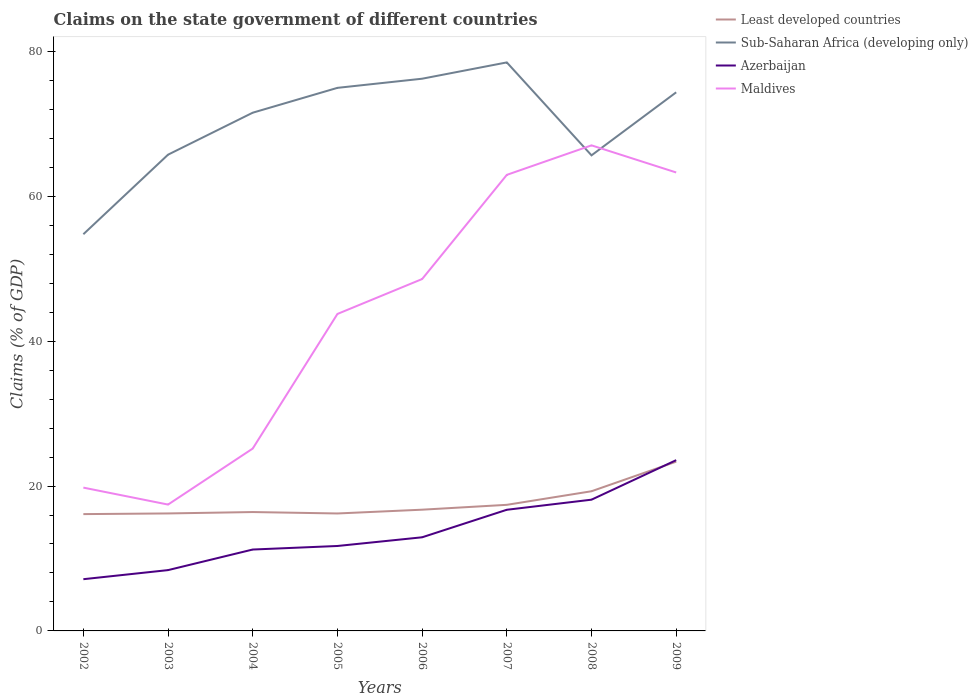How many different coloured lines are there?
Your response must be concise. 4. Does the line corresponding to Maldives intersect with the line corresponding to Least developed countries?
Your response must be concise. No. Across all years, what is the maximum percentage of GDP claimed on the state government in Sub-Saharan Africa (developing only)?
Offer a very short reply. 54.76. What is the total percentage of GDP claimed on the state government in Azerbaijan in the graph?
Your response must be concise. -1.69. What is the difference between the highest and the second highest percentage of GDP claimed on the state government in Maldives?
Provide a short and direct response. 49.59. Is the percentage of GDP claimed on the state government in Maldives strictly greater than the percentage of GDP claimed on the state government in Azerbaijan over the years?
Offer a terse response. No. How many lines are there?
Provide a short and direct response. 4. What is the difference between two consecutive major ticks on the Y-axis?
Provide a short and direct response. 20. Are the values on the major ticks of Y-axis written in scientific E-notation?
Make the answer very short. No. Does the graph contain any zero values?
Your response must be concise. No. How many legend labels are there?
Make the answer very short. 4. What is the title of the graph?
Offer a terse response. Claims on the state government of different countries. Does "East Asia (all income levels)" appear as one of the legend labels in the graph?
Make the answer very short. No. What is the label or title of the Y-axis?
Make the answer very short. Claims (% of GDP). What is the Claims (% of GDP) in Least developed countries in 2002?
Provide a short and direct response. 16.13. What is the Claims (% of GDP) in Sub-Saharan Africa (developing only) in 2002?
Offer a very short reply. 54.76. What is the Claims (% of GDP) of Azerbaijan in 2002?
Provide a short and direct response. 7.14. What is the Claims (% of GDP) of Maldives in 2002?
Your response must be concise. 19.78. What is the Claims (% of GDP) in Least developed countries in 2003?
Your response must be concise. 16.22. What is the Claims (% of GDP) of Sub-Saharan Africa (developing only) in 2003?
Ensure brevity in your answer.  65.75. What is the Claims (% of GDP) in Azerbaijan in 2003?
Give a very brief answer. 8.4. What is the Claims (% of GDP) in Maldives in 2003?
Your answer should be very brief. 17.44. What is the Claims (% of GDP) of Least developed countries in 2004?
Provide a short and direct response. 16.41. What is the Claims (% of GDP) of Sub-Saharan Africa (developing only) in 2004?
Give a very brief answer. 71.54. What is the Claims (% of GDP) in Azerbaijan in 2004?
Offer a very short reply. 11.24. What is the Claims (% of GDP) in Maldives in 2004?
Offer a very short reply. 25.18. What is the Claims (% of GDP) in Least developed countries in 2005?
Provide a short and direct response. 16.21. What is the Claims (% of GDP) of Sub-Saharan Africa (developing only) in 2005?
Give a very brief answer. 74.97. What is the Claims (% of GDP) in Azerbaijan in 2005?
Your answer should be very brief. 11.73. What is the Claims (% of GDP) of Maldives in 2005?
Keep it short and to the point. 43.76. What is the Claims (% of GDP) in Least developed countries in 2006?
Ensure brevity in your answer.  16.74. What is the Claims (% of GDP) of Sub-Saharan Africa (developing only) in 2006?
Give a very brief answer. 76.23. What is the Claims (% of GDP) of Azerbaijan in 2006?
Give a very brief answer. 12.93. What is the Claims (% of GDP) of Maldives in 2006?
Make the answer very short. 48.58. What is the Claims (% of GDP) in Least developed countries in 2007?
Offer a terse response. 17.41. What is the Claims (% of GDP) in Sub-Saharan Africa (developing only) in 2007?
Provide a succinct answer. 78.48. What is the Claims (% of GDP) in Azerbaijan in 2007?
Keep it short and to the point. 16.73. What is the Claims (% of GDP) of Maldives in 2007?
Make the answer very short. 62.96. What is the Claims (% of GDP) of Least developed countries in 2008?
Provide a succinct answer. 19.28. What is the Claims (% of GDP) of Sub-Saharan Africa (developing only) in 2008?
Provide a short and direct response. 65.65. What is the Claims (% of GDP) of Azerbaijan in 2008?
Your response must be concise. 18.12. What is the Claims (% of GDP) of Maldives in 2008?
Your response must be concise. 67.03. What is the Claims (% of GDP) in Least developed countries in 2009?
Offer a very short reply. 23.37. What is the Claims (% of GDP) of Sub-Saharan Africa (developing only) in 2009?
Provide a short and direct response. 74.35. What is the Claims (% of GDP) of Azerbaijan in 2009?
Your answer should be compact. 23.58. What is the Claims (% of GDP) in Maldives in 2009?
Your answer should be compact. 63.29. Across all years, what is the maximum Claims (% of GDP) in Least developed countries?
Ensure brevity in your answer.  23.37. Across all years, what is the maximum Claims (% of GDP) in Sub-Saharan Africa (developing only)?
Your response must be concise. 78.48. Across all years, what is the maximum Claims (% of GDP) in Azerbaijan?
Make the answer very short. 23.58. Across all years, what is the maximum Claims (% of GDP) in Maldives?
Keep it short and to the point. 67.03. Across all years, what is the minimum Claims (% of GDP) in Least developed countries?
Give a very brief answer. 16.13. Across all years, what is the minimum Claims (% of GDP) in Sub-Saharan Africa (developing only)?
Provide a succinct answer. 54.76. Across all years, what is the minimum Claims (% of GDP) in Azerbaijan?
Offer a terse response. 7.14. Across all years, what is the minimum Claims (% of GDP) in Maldives?
Make the answer very short. 17.44. What is the total Claims (% of GDP) of Least developed countries in the graph?
Provide a short and direct response. 141.76. What is the total Claims (% of GDP) in Sub-Saharan Africa (developing only) in the graph?
Make the answer very short. 561.74. What is the total Claims (% of GDP) in Azerbaijan in the graph?
Offer a terse response. 109.84. What is the total Claims (% of GDP) of Maldives in the graph?
Ensure brevity in your answer.  348.02. What is the difference between the Claims (% of GDP) of Least developed countries in 2002 and that in 2003?
Your answer should be very brief. -0.09. What is the difference between the Claims (% of GDP) of Sub-Saharan Africa (developing only) in 2002 and that in 2003?
Offer a very short reply. -10.98. What is the difference between the Claims (% of GDP) in Azerbaijan in 2002 and that in 2003?
Your answer should be compact. -1.25. What is the difference between the Claims (% of GDP) of Maldives in 2002 and that in 2003?
Make the answer very short. 2.34. What is the difference between the Claims (% of GDP) in Least developed countries in 2002 and that in 2004?
Your answer should be compact. -0.28. What is the difference between the Claims (% of GDP) in Sub-Saharan Africa (developing only) in 2002 and that in 2004?
Your answer should be very brief. -16.78. What is the difference between the Claims (% of GDP) in Azerbaijan in 2002 and that in 2004?
Provide a short and direct response. -4.1. What is the difference between the Claims (% of GDP) of Maldives in 2002 and that in 2004?
Your answer should be compact. -5.39. What is the difference between the Claims (% of GDP) of Least developed countries in 2002 and that in 2005?
Give a very brief answer. -0.09. What is the difference between the Claims (% of GDP) in Sub-Saharan Africa (developing only) in 2002 and that in 2005?
Provide a succinct answer. -20.21. What is the difference between the Claims (% of GDP) of Azerbaijan in 2002 and that in 2005?
Provide a short and direct response. -4.58. What is the difference between the Claims (% of GDP) of Maldives in 2002 and that in 2005?
Keep it short and to the point. -23.97. What is the difference between the Claims (% of GDP) in Least developed countries in 2002 and that in 2006?
Your response must be concise. -0.61. What is the difference between the Claims (% of GDP) of Sub-Saharan Africa (developing only) in 2002 and that in 2006?
Provide a succinct answer. -21.47. What is the difference between the Claims (% of GDP) of Azerbaijan in 2002 and that in 2006?
Offer a very short reply. -5.78. What is the difference between the Claims (% of GDP) in Maldives in 2002 and that in 2006?
Keep it short and to the point. -28.79. What is the difference between the Claims (% of GDP) of Least developed countries in 2002 and that in 2007?
Your answer should be very brief. -1.28. What is the difference between the Claims (% of GDP) in Sub-Saharan Africa (developing only) in 2002 and that in 2007?
Provide a short and direct response. -23.72. What is the difference between the Claims (% of GDP) of Azerbaijan in 2002 and that in 2007?
Ensure brevity in your answer.  -9.58. What is the difference between the Claims (% of GDP) of Maldives in 2002 and that in 2007?
Your answer should be compact. -43.17. What is the difference between the Claims (% of GDP) in Least developed countries in 2002 and that in 2008?
Provide a succinct answer. -3.16. What is the difference between the Claims (% of GDP) of Sub-Saharan Africa (developing only) in 2002 and that in 2008?
Your answer should be compact. -10.89. What is the difference between the Claims (% of GDP) of Azerbaijan in 2002 and that in 2008?
Offer a terse response. -10.98. What is the difference between the Claims (% of GDP) of Maldives in 2002 and that in 2008?
Offer a very short reply. -47.25. What is the difference between the Claims (% of GDP) in Least developed countries in 2002 and that in 2009?
Make the answer very short. -7.24. What is the difference between the Claims (% of GDP) of Sub-Saharan Africa (developing only) in 2002 and that in 2009?
Provide a succinct answer. -19.59. What is the difference between the Claims (% of GDP) in Azerbaijan in 2002 and that in 2009?
Your response must be concise. -16.43. What is the difference between the Claims (% of GDP) in Maldives in 2002 and that in 2009?
Provide a short and direct response. -43.51. What is the difference between the Claims (% of GDP) in Least developed countries in 2003 and that in 2004?
Ensure brevity in your answer.  -0.19. What is the difference between the Claims (% of GDP) of Sub-Saharan Africa (developing only) in 2003 and that in 2004?
Keep it short and to the point. -5.8. What is the difference between the Claims (% of GDP) in Azerbaijan in 2003 and that in 2004?
Provide a succinct answer. -2.84. What is the difference between the Claims (% of GDP) in Maldives in 2003 and that in 2004?
Offer a terse response. -7.74. What is the difference between the Claims (% of GDP) of Least developed countries in 2003 and that in 2005?
Provide a short and direct response. 0. What is the difference between the Claims (% of GDP) of Sub-Saharan Africa (developing only) in 2003 and that in 2005?
Offer a very short reply. -9.22. What is the difference between the Claims (% of GDP) of Azerbaijan in 2003 and that in 2005?
Provide a short and direct response. -3.33. What is the difference between the Claims (% of GDP) in Maldives in 2003 and that in 2005?
Offer a very short reply. -26.32. What is the difference between the Claims (% of GDP) in Least developed countries in 2003 and that in 2006?
Provide a short and direct response. -0.52. What is the difference between the Claims (% of GDP) of Sub-Saharan Africa (developing only) in 2003 and that in 2006?
Your answer should be very brief. -10.49. What is the difference between the Claims (% of GDP) of Azerbaijan in 2003 and that in 2006?
Your answer should be compact. -4.53. What is the difference between the Claims (% of GDP) of Maldives in 2003 and that in 2006?
Offer a terse response. -31.13. What is the difference between the Claims (% of GDP) in Least developed countries in 2003 and that in 2007?
Your response must be concise. -1.19. What is the difference between the Claims (% of GDP) of Sub-Saharan Africa (developing only) in 2003 and that in 2007?
Give a very brief answer. -12.74. What is the difference between the Claims (% of GDP) of Azerbaijan in 2003 and that in 2007?
Your answer should be compact. -8.33. What is the difference between the Claims (% of GDP) in Maldives in 2003 and that in 2007?
Your answer should be compact. -45.52. What is the difference between the Claims (% of GDP) in Least developed countries in 2003 and that in 2008?
Your answer should be compact. -3.06. What is the difference between the Claims (% of GDP) of Sub-Saharan Africa (developing only) in 2003 and that in 2008?
Make the answer very short. 0.09. What is the difference between the Claims (% of GDP) of Azerbaijan in 2003 and that in 2008?
Give a very brief answer. -9.72. What is the difference between the Claims (% of GDP) in Maldives in 2003 and that in 2008?
Offer a very short reply. -49.59. What is the difference between the Claims (% of GDP) of Least developed countries in 2003 and that in 2009?
Your response must be concise. -7.15. What is the difference between the Claims (% of GDP) in Sub-Saharan Africa (developing only) in 2003 and that in 2009?
Provide a succinct answer. -8.61. What is the difference between the Claims (% of GDP) of Azerbaijan in 2003 and that in 2009?
Your response must be concise. -15.18. What is the difference between the Claims (% of GDP) in Maldives in 2003 and that in 2009?
Keep it short and to the point. -45.85. What is the difference between the Claims (% of GDP) in Least developed countries in 2004 and that in 2005?
Offer a terse response. 0.2. What is the difference between the Claims (% of GDP) of Sub-Saharan Africa (developing only) in 2004 and that in 2005?
Your answer should be compact. -3.43. What is the difference between the Claims (% of GDP) of Azerbaijan in 2004 and that in 2005?
Offer a very short reply. -0.49. What is the difference between the Claims (% of GDP) of Maldives in 2004 and that in 2005?
Keep it short and to the point. -18.58. What is the difference between the Claims (% of GDP) of Least developed countries in 2004 and that in 2006?
Your answer should be very brief. -0.33. What is the difference between the Claims (% of GDP) in Sub-Saharan Africa (developing only) in 2004 and that in 2006?
Ensure brevity in your answer.  -4.69. What is the difference between the Claims (% of GDP) of Azerbaijan in 2004 and that in 2006?
Provide a short and direct response. -1.69. What is the difference between the Claims (% of GDP) of Maldives in 2004 and that in 2006?
Provide a succinct answer. -23.4. What is the difference between the Claims (% of GDP) in Least developed countries in 2004 and that in 2007?
Offer a terse response. -1. What is the difference between the Claims (% of GDP) in Sub-Saharan Africa (developing only) in 2004 and that in 2007?
Make the answer very short. -6.94. What is the difference between the Claims (% of GDP) in Azerbaijan in 2004 and that in 2007?
Make the answer very short. -5.49. What is the difference between the Claims (% of GDP) of Maldives in 2004 and that in 2007?
Offer a terse response. -37.78. What is the difference between the Claims (% of GDP) of Least developed countries in 2004 and that in 2008?
Make the answer very short. -2.87. What is the difference between the Claims (% of GDP) of Sub-Saharan Africa (developing only) in 2004 and that in 2008?
Your answer should be compact. 5.89. What is the difference between the Claims (% of GDP) of Azerbaijan in 2004 and that in 2008?
Provide a succinct answer. -6.88. What is the difference between the Claims (% of GDP) of Maldives in 2004 and that in 2008?
Your answer should be compact. -41.85. What is the difference between the Claims (% of GDP) in Least developed countries in 2004 and that in 2009?
Provide a succinct answer. -6.96. What is the difference between the Claims (% of GDP) in Sub-Saharan Africa (developing only) in 2004 and that in 2009?
Provide a succinct answer. -2.81. What is the difference between the Claims (% of GDP) of Azerbaijan in 2004 and that in 2009?
Offer a very short reply. -12.34. What is the difference between the Claims (% of GDP) of Maldives in 2004 and that in 2009?
Provide a short and direct response. -38.11. What is the difference between the Claims (% of GDP) of Least developed countries in 2005 and that in 2006?
Make the answer very short. -0.52. What is the difference between the Claims (% of GDP) in Sub-Saharan Africa (developing only) in 2005 and that in 2006?
Your answer should be compact. -1.26. What is the difference between the Claims (% of GDP) of Azerbaijan in 2005 and that in 2006?
Provide a short and direct response. -1.2. What is the difference between the Claims (% of GDP) of Maldives in 2005 and that in 2006?
Provide a succinct answer. -4.82. What is the difference between the Claims (% of GDP) in Least developed countries in 2005 and that in 2007?
Keep it short and to the point. -1.19. What is the difference between the Claims (% of GDP) of Sub-Saharan Africa (developing only) in 2005 and that in 2007?
Offer a terse response. -3.51. What is the difference between the Claims (% of GDP) in Azerbaijan in 2005 and that in 2007?
Your answer should be compact. -5. What is the difference between the Claims (% of GDP) of Maldives in 2005 and that in 2007?
Keep it short and to the point. -19.2. What is the difference between the Claims (% of GDP) in Least developed countries in 2005 and that in 2008?
Keep it short and to the point. -3.07. What is the difference between the Claims (% of GDP) of Sub-Saharan Africa (developing only) in 2005 and that in 2008?
Keep it short and to the point. 9.32. What is the difference between the Claims (% of GDP) of Azerbaijan in 2005 and that in 2008?
Your response must be concise. -6.39. What is the difference between the Claims (% of GDP) in Maldives in 2005 and that in 2008?
Offer a very short reply. -23.27. What is the difference between the Claims (% of GDP) of Least developed countries in 2005 and that in 2009?
Offer a very short reply. -7.15. What is the difference between the Claims (% of GDP) of Sub-Saharan Africa (developing only) in 2005 and that in 2009?
Your answer should be compact. 0.62. What is the difference between the Claims (% of GDP) in Azerbaijan in 2005 and that in 2009?
Provide a short and direct response. -11.85. What is the difference between the Claims (% of GDP) of Maldives in 2005 and that in 2009?
Keep it short and to the point. -19.53. What is the difference between the Claims (% of GDP) in Least developed countries in 2006 and that in 2007?
Give a very brief answer. -0.67. What is the difference between the Claims (% of GDP) of Sub-Saharan Africa (developing only) in 2006 and that in 2007?
Provide a short and direct response. -2.25. What is the difference between the Claims (% of GDP) of Azerbaijan in 2006 and that in 2007?
Ensure brevity in your answer.  -3.8. What is the difference between the Claims (% of GDP) in Maldives in 2006 and that in 2007?
Your response must be concise. -14.38. What is the difference between the Claims (% of GDP) in Least developed countries in 2006 and that in 2008?
Make the answer very short. -2.55. What is the difference between the Claims (% of GDP) in Sub-Saharan Africa (developing only) in 2006 and that in 2008?
Ensure brevity in your answer.  10.58. What is the difference between the Claims (% of GDP) in Azerbaijan in 2006 and that in 2008?
Provide a short and direct response. -5.19. What is the difference between the Claims (% of GDP) in Maldives in 2006 and that in 2008?
Offer a terse response. -18.46. What is the difference between the Claims (% of GDP) in Least developed countries in 2006 and that in 2009?
Ensure brevity in your answer.  -6.63. What is the difference between the Claims (% of GDP) of Sub-Saharan Africa (developing only) in 2006 and that in 2009?
Your response must be concise. 1.88. What is the difference between the Claims (% of GDP) in Azerbaijan in 2006 and that in 2009?
Make the answer very short. -10.65. What is the difference between the Claims (% of GDP) of Maldives in 2006 and that in 2009?
Give a very brief answer. -14.71. What is the difference between the Claims (% of GDP) in Least developed countries in 2007 and that in 2008?
Make the answer very short. -1.88. What is the difference between the Claims (% of GDP) of Sub-Saharan Africa (developing only) in 2007 and that in 2008?
Your answer should be very brief. 12.83. What is the difference between the Claims (% of GDP) of Azerbaijan in 2007 and that in 2008?
Provide a succinct answer. -1.39. What is the difference between the Claims (% of GDP) of Maldives in 2007 and that in 2008?
Your answer should be compact. -4.07. What is the difference between the Claims (% of GDP) of Least developed countries in 2007 and that in 2009?
Keep it short and to the point. -5.96. What is the difference between the Claims (% of GDP) of Sub-Saharan Africa (developing only) in 2007 and that in 2009?
Offer a very short reply. 4.13. What is the difference between the Claims (% of GDP) of Azerbaijan in 2007 and that in 2009?
Keep it short and to the point. -6.85. What is the difference between the Claims (% of GDP) of Maldives in 2007 and that in 2009?
Offer a very short reply. -0.33. What is the difference between the Claims (% of GDP) of Least developed countries in 2008 and that in 2009?
Provide a short and direct response. -4.08. What is the difference between the Claims (% of GDP) of Sub-Saharan Africa (developing only) in 2008 and that in 2009?
Offer a very short reply. -8.7. What is the difference between the Claims (% of GDP) of Azerbaijan in 2008 and that in 2009?
Keep it short and to the point. -5.46. What is the difference between the Claims (% of GDP) in Maldives in 2008 and that in 2009?
Offer a terse response. 3.74. What is the difference between the Claims (% of GDP) of Least developed countries in 2002 and the Claims (% of GDP) of Sub-Saharan Africa (developing only) in 2003?
Offer a very short reply. -49.62. What is the difference between the Claims (% of GDP) of Least developed countries in 2002 and the Claims (% of GDP) of Azerbaijan in 2003?
Provide a short and direct response. 7.73. What is the difference between the Claims (% of GDP) in Least developed countries in 2002 and the Claims (% of GDP) in Maldives in 2003?
Keep it short and to the point. -1.32. What is the difference between the Claims (% of GDP) of Sub-Saharan Africa (developing only) in 2002 and the Claims (% of GDP) of Azerbaijan in 2003?
Offer a very short reply. 46.37. What is the difference between the Claims (% of GDP) in Sub-Saharan Africa (developing only) in 2002 and the Claims (% of GDP) in Maldives in 2003?
Offer a very short reply. 37.32. What is the difference between the Claims (% of GDP) of Azerbaijan in 2002 and the Claims (% of GDP) of Maldives in 2003?
Offer a terse response. -10.3. What is the difference between the Claims (% of GDP) in Least developed countries in 2002 and the Claims (% of GDP) in Sub-Saharan Africa (developing only) in 2004?
Your answer should be compact. -55.42. What is the difference between the Claims (% of GDP) of Least developed countries in 2002 and the Claims (% of GDP) of Azerbaijan in 2004?
Make the answer very short. 4.89. What is the difference between the Claims (% of GDP) in Least developed countries in 2002 and the Claims (% of GDP) in Maldives in 2004?
Make the answer very short. -9.05. What is the difference between the Claims (% of GDP) in Sub-Saharan Africa (developing only) in 2002 and the Claims (% of GDP) in Azerbaijan in 2004?
Make the answer very short. 43.53. What is the difference between the Claims (% of GDP) in Sub-Saharan Africa (developing only) in 2002 and the Claims (% of GDP) in Maldives in 2004?
Offer a very short reply. 29.59. What is the difference between the Claims (% of GDP) in Azerbaijan in 2002 and the Claims (% of GDP) in Maldives in 2004?
Make the answer very short. -18.04. What is the difference between the Claims (% of GDP) of Least developed countries in 2002 and the Claims (% of GDP) of Sub-Saharan Africa (developing only) in 2005?
Give a very brief answer. -58.84. What is the difference between the Claims (% of GDP) of Least developed countries in 2002 and the Claims (% of GDP) of Maldives in 2005?
Offer a very short reply. -27.63. What is the difference between the Claims (% of GDP) of Sub-Saharan Africa (developing only) in 2002 and the Claims (% of GDP) of Azerbaijan in 2005?
Your answer should be very brief. 43.04. What is the difference between the Claims (% of GDP) in Sub-Saharan Africa (developing only) in 2002 and the Claims (% of GDP) in Maldives in 2005?
Your response must be concise. 11.01. What is the difference between the Claims (% of GDP) of Azerbaijan in 2002 and the Claims (% of GDP) of Maldives in 2005?
Provide a short and direct response. -36.62. What is the difference between the Claims (% of GDP) of Least developed countries in 2002 and the Claims (% of GDP) of Sub-Saharan Africa (developing only) in 2006?
Your answer should be compact. -60.11. What is the difference between the Claims (% of GDP) in Least developed countries in 2002 and the Claims (% of GDP) in Azerbaijan in 2006?
Make the answer very short. 3.2. What is the difference between the Claims (% of GDP) of Least developed countries in 2002 and the Claims (% of GDP) of Maldives in 2006?
Provide a short and direct response. -32.45. What is the difference between the Claims (% of GDP) in Sub-Saharan Africa (developing only) in 2002 and the Claims (% of GDP) in Azerbaijan in 2006?
Your answer should be compact. 41.84. What is the difference between the Claims (% of GDP) of Sub-Saharan Africa (developing only) in 2002 and the Claims (% of GDP) of Maldives in 2006?
Your answer should be compact. 6.19. What is the difference between the Claims (% of GDP) in Azerbaijan in 2002 and the Claims (% of GDP) in Maldives in 2006?
Offer a very short reply. -41.43. What is the difference between the Claims (% of GDP) of Least developed countries in 2002 and the Claims (% of GDP) of Sub-Saharan Africa (developing only) in 2007?
Your answer should be compact. -62.36. What is the difference between the Claims (% of GDP) of Least developed countries in 2002 and the Claims (% of GDP) of Azerbaijan in 2007?
Make the answer very short. -0.6. What is the difference between the Claims (% of GDP) in Least developed countries in 2002 and the Claims (% of GDP) in Maldives in 2007?
Your answer should be very brief. -46.83. What is the difference between the Claims (% of GDP) in Sub-Saharan Africa (developing only) in 2002 and the Claims (% of GDP) in Azerbaijan in 2007?
Your answer should be very brief. 38.04. What is the difference between the Claims (% of GDP) of Sub-Saharan Africa (developing only) in 2002 and the Claims (% of GDP) of Maldives in 2007?
Provide a short and direct response. -8.19. What is the difference between the Claims (% of GDP) in Azerbaijan in 2002 and the Claims (% of GDP) in Maldives in 2007?
Your answer should be very brief. -55.82. What is the difference between the Claims (% of GDP) in Least developed countries in 2002 and the Claims (% of GDP) in Sub-Saharan Africa (developing only) in 2008?
Make the answer very short. -49.53. What is the difference between the Claims (% of GDP) in Least developed countries in 2002 and the Claims (% of GDP) in Azerbaijan in 2008?
Offer a terse response. -1.99. What is the difference between the Claims (% of GDP) of Least developed countries in 2002 and the Claims (% of GDP) of Maldives in 2008?
Your response must be concise. -50.91. What is the difference between the Claims (% of GDP) of Sub-Saharan Africa (developing only) in 2002 and the Claims (% of GDP) of Azerbaijan in 2008?
Your response must be concise. 36.65. What is the difference between the Claims (% of GDP) of Sub-Saharan Africa (developing only) in 2002 and the Claims (% of GDP) of Maldives in 2008?
Ensure brevity in your answer.  -12.27. What is the difference between the Claims (% of GDP) in Azerbaijan in 2002 and the Claims (% of GDP) in Maldives in 2008?
Offer a terse response. -59.89. What is the difference between the Claims (% of GDP) in Least developed countries in 2002 and the Claims (% of GDP) in Sub-Saharan Africa (developing only) in 2009?
Give a very brief answer. -58.23. What is the difference between the Claims (% of GDP) in Least developed countries in 2002 and the Claims (% of GDP) in Azerbaijan in 2009?
Your answer should be very brief. -7.45. What is the difference between the Claims (% of GDP) in Least developed countries in 2002 and the Claims (% of GDP) in Maldives in 2009?
Your answer should be compact. -47.16. What is the difference between the Claims (% of GDP) of Sub-Saharan Africa (developing only) in 2002 and the Claims (% of GDP) of Azerbaijan in 2009?
Your answer should be compact. 31.19. What is the difference between the Claims (% of GDP) of Sub-Saharan Africa (developing only) in 2002 and the Claims (% of GDP) of Maldives in 2009?
Keep it short and to the point. -8.53. What is the difference between the Claims (% of GDP) in Azerbaijan in 2002 and the Claims (% of GDP) in Maldives in 2009?
Ensure brevity in your answer.  -56.15. What is the difference between the Claims (% of GDP) in Least developed countries in 2003 and the Claims (% of GDP) in Sub-Saharan Africa (developing only) in 2004?
Offer a terse response. -55.32. What is the difference between the Claims (% of GDP) of Least developed countries in 2003 and the Claims (% of GDP) of Azerbaijan in 2004?
Ensure brevity in your answer.  4.98. What is the difference between the Claims (% of GDP) of Least developed countries in 2003 and the Claims (% of GDP) of Maldives in 2004?
Provide a short and direct response. -8.96. What is the difference between the Claims (% of GDP) in Sub-Saharan Africa (developing only) in 2003 and the Claims (% of GDP) in Azerbaijan in 2004?
Offer a very short reply. 54.51. What is the difference between the Claims (% of GDP) of Sub-Saharan Africa (developing only) in 2003 and the Claims (% of GDP) of Maldives in 2004?
Offer a terse response. 40.57. What is the difference between the Claims (% of GDP) of Azerbaijan in 2003 and the Claims (% of GDP) of Maldives in 2004?
Provide a succinct answer. -16.78. What is the difference between the Claims (% of GDP) of Least developed countries in 2003 and the Claims (% of GDP) of Sub-Saharan Africa (developing only) in 2005?
Provide a succinct answer. -58.75. What is the difference between the Claims (% of GDP) in Least developed countries in 2003 and the Claims (% of GDP) in Azerbaijan in 2005?
Ensure brevity in your answer.  4.49. What is the difference between the Claims (% of GDP) in Least developed countries in 2003 and the Claims (% of GDP) in Maldives in 2005?
Provide a succinct answer. -27.54. What is the difference between the Claims (% of GDP) in Sub-Saharan Africa (developing only) in 2003 and the Claims (% of GDP) in Azerbaijan in 2005?
Give a very brief answer. 54.02. What is the difference between the Claims (% of GDP) in Sub-Saharan Africa (developing only) in 2003 and the Claims (% of GDP) in Maldives in 2005?
Your answer should be very brief. 21.99. What is the difference between the Claims (% of GDP) of Azerbaijan in 2003 and the Claims (% of GDP) of Maldives in 2005?
Give a very brief answer. -35.36. What is the difference between the Claims (% of GDP) of Least developed countries in 2003 and the Claims (% of GDP) of Sub-Saharan Africa (developing only) in 2006?
Offer a terse response. -60.01. What is the difference between the Claims (% of GDP) of Least developed countries in 2003 and the Claims (% of GDP) of Azerbaijan in 2006?
Offer a terse response. 3.29. What is the difference between the Claims (% of GDP) in Least developed countries in 2003 and the Claims (% of GDP) in Maldives in 2006?
Provide a succinct answer. -32.36. What is the difference between the Claims (% of GDP) of Sub-Saharan Africa (developing only) in 2003 and the Claims (% of GDP) of Azerbaijan in 2006?
Your answer should be compact. 52.82. What is the difference between the Claims (% of GDP) of Sub-Saharan Africa (developing only) in 2003 and the Claims (% of GDP) of Maldives in 2006?
Your response must be concise. 17.17. What is the difference between the Claims (% of GDP) of Azerbaijan in 2003 and the Claims (% of GDP) of Maldives in 2006?
Give a very brief answer. -40.18. What is the difference between the Claims (% of GDP) in Least developed countries in 2003 and the Claims (% of GDP) in Sub-Saharan Africa (developing only) in 2007?
Offer a very short reply. -62.26. What is the difference between the Claims (% of GDP) of Least developed countries in 2003 and the Claims (% of GDP) of Azerbaijan in 2007?
Give a very brief answer. -0.51. What is the difference between the Claims (% of GDP) of Least developed countries in 2003 and the Claims (% of GDP) of Maldives in 2007?
Give a very brief answer. -46.74. What is the difference between the Claims (% of GDP) in Sub-Saharan Africa (developing only) in 2003 and the Claims (% of GDP) in Azerbaijan in 2007?
Your answer should be very brief. 49.02. What is the difference between the Claims (% of GDP) in Sub-Saharan Africa (developing only) in 2003 and the Claims (% of GDP) in Maldives in 2007?
Your response must be concise. 2.79. What is the difference between the Claims (% of GDP) in Azerbaijan in 2003 and the Claims (% of GDP) in Maldives in 2007?
Ensure brevity in your answer.  -54.56. What is the difference between the Claims (% of GDP) in Least developed countries in 2003 and the Claims (% of GDP) in Sub-Saharan Africa (developing only) in 2008?
Keep it short and to the point. -49.43. What is the difference between the Claims (% of GDP) of Least developed countries in 2003 and the Claims (% of GDP) of Azerbaijan in 2008?
Make the answer very short. -1.9. What is the difference between the Claims (% of GDP) in Least developed countries in 2003 and the Claims (% of GDP) in Maldives in 2008?
Keep it short and to the point. -50.81. What is the difference between the Claims (% of GDP) in Sub-Saharan Africa (developing only) in 2003 and the Claims (% of GDP) in Azerbaijan in 2008?
Your answer should be very brief. 47.63. What is the difference between the Claims (% of GDP) in Sub-Saharan Africa (developing only) in 2003 and the Claims (% of GDP) in Maldives in 2008?
Your response must be concise. -1.29. What is the difference between the Claims (% of GDP) in Azerbaijan in 2003 and the Claims (% of GDP) in Maldives in 2008?
Give a very brief answer. -58.64. What is the difference between the Claims (% of GDP) in Least developed countries in 2003 and the Claims (% of GDP) in Sub-Saharan Africa (developing only) in 2009?
Your answer should be very brief. -58.14. What is the difference between the Claims (% of GDP) in Least developed countries in 2003 and the Claims (% of GDP) in Azerbaijan in 2009?
Make the answer very short. -7.36. What is the difference between the Claims (% of GDP) in Least developed countries in 2003 and the Claims (% of GDP) in Maldives in 2009?
Your response must be concise. -47.07. What is the difference between the Claims (% of GDP) in Sub-Saharan Africa (developing only) in 2003 and the Claims (% of GDP) in Azerbaijan in 2009?
Give a very brief answer. 42.17. What is the difference between the Claims (% of GDP) of Sub-Saharan Africa (developing only) in 2003 and the Claims (% of GDP) of Maldives in 2009?
Provide a succinct answer. 2.46. What is the difference between the Claims (% of GDP) of Azerbaijan in 2003 and the Claims (% of GDP) of Maldives in 2009?
Your answer should be compact. -54.89. What is the difference between the Claims (% of GDP) in Least developed countries in 2004 and the Claims (% of GDP) in Sub-Saharan Africa (developing only) in 2005?
Your response must be concise. -58.56. What is the difference between the Claims (% of GDP) of Least developed countries in 2004 and the Claims (% of GDP) of Azerbaijan in 2005?
Your response must be concise. 4.68. What is the difference between the Claims (% of GDP) in Least developed countries in 2004 and the Claims (% of GDP) in Maldives in 2005?
Give a very brief answer. -27.35. What is the difference between the Claims (% of GDP) of Sub-Saharan Africa (developing only) in 2004 and the Claims (% of GDP) of Azerbaijan in 2005?
Offer a very short reply. 59.82. What is the difference between the Claims (% of GDP) in Sub-Saharan Africa (developing only) in 2004 and the Claims (% of GDP) in Maldives in 2005?
Provide a short and direct response. 27.78. What is the difference between the Claims (% of GDP) in Azerbaijan in 2004 and the Claims (% of GDP) in Maldives in 2005?
Give a very brief answer. -32.52. What is the difference between the Claims (% of GDP) in Least developed countries in 2004 and the Claims (% of GDP) in Sub-Saharan Africa (developing only) in 2006?
Offer a terse response. -59.82. What is the difference between the Claims (% of GDP) of Least developed countries in 2004 and the Claims (% of GDP) of Azerbaijan in 2006?
Give a very brief answer. 3.48. What is the difference between the Claims (% of GDP) of Least developed countries in 2004 and the Claims (% of GDP) of Maldives in 2006?
Offer a very short reply. -32.17. What is the difference between the Claims (% of GDP) of Sub-Saharan Africa (developing only) in 2004 and the Claims (% of GDP) of Azerbaijan in 2006?
Provide a succinct answer. 58.62. What is the difference between the Claims (% of GDP) of Sub-Saharan Africa (developing only) in 2004 and the Claims (% of GDP) of Maldives in 2006?
Ensure brevity in your answer.  22.97. What is the difference between the Claims (% of GDP) of Azerbaijan in 2004 and the Claims (% of GDP) of Maldives in 2006?
Provide a succinct answer. -37.34. What is the difference between the Claims (% of GDP) of Least developed countries in 2004 and the Claims (% of GDP) of Sub-Saharan Africa (developing only) in 2007?
Give a very brief answer. -62.07. What is the difference between the Claims (% of GDP) of Least developed countries in 2004 and the Claims (% of GDP) of Azerbaijan in 2007?
Your answer should be very brief. -0.32. What is the difference between the Claims (% of GDP) in Least developed countries in 2004 and the Claims (% of GDP) in Maldives in 2007?
Offer a terse response. -46.55. What is the difference between the Claims (% of GDP) of Sub-Saharan Africa (developing only) in 2004 and the Claims (% of GDP) of Azerbaijan in 2007?
Offer a very short reply. 54.82. What is the difference between the Claims (% of GDP) in Sub-Saharan Africa (developing only) in 2004 and the Claims (% of GDP) in Maldives in 2007?
Give a very brief answer. 8.58. What is the difference between the Claims (% of GDP) of Azerbaijan in 2004 and the Claims (% of GDP) of Maldives in 2007?
Your answer should be very brief. -51.72. What is the difference between the Claims (% of GDP) in Least developed countries in 2004 and the Claims (% of GDP) in Sub-Saharan Africa (developing only) in 2008?
Ensure brevity in your answer.  -49.24. What is the difference between the Claims (% of GDP) of Least developed countries in 2004 and the Claims (% of GDP) of Azerbaijan in 2008?
Your response must be concise. -1.71. What is the difference between the Claims (% of GDP) in Least developed countries in 2004 and the Claims (% of GDP) in Maldives in 2008?
Keep it short and to the point. -50.62. What is the difference between the Claims (% of GDP) of Sub-Saharan Africa (developing only) in 2004 and the Claims (% of GDP) of Azerbaijan in 2008?
Make the answer very short. 53.42. What is the difference between the Claims (% of GDP) in Sub-Saharan Africa (developing only) in 2004 and the Claims (% of GDP) in Maldives in 2008?
Provide a short and direct response. 4.51. What is the difference between the Claims (% of GDP) in Azerbaijan in 2004 and the Claims (% of GDP) in Maldives in 2008?
Give a very brief answer. -55.8. What is the difference between the Claims (% of GDP) in Least developed countries in 2004 and the Claims (% of GDP) in Sub-Saharan Africa (developing only) in 2009?
Offer a very short reply. -57.94. What is the difference between the Claims (% of GDP) in Least developed countries in 2004 and the Claims (% of GDP) in Azerbaijan in 2009?
Ensure brevity in your answer.  -7.17. What is the difference between the Claims (% of GDP) in Least developed countries in 2004 and the Claims (% of GDP) in Maldives in 2009?
Provide a succinct answer. -46.88. What is the difference between the Claims (% of GDP) in Sub-Saharan Africa (developing only) in 2004 and the Claims (% of GDP) in Azerbaijan in 2009?
Offer a terse response. 47.97. What is the difference between the Claims (% of GDP) of Sub-Saharan Africa (developing only) in 2004 and the Claims (% of GDP) of Maldives in 2009?
Your answer should be very brief. 8.25. What is the difference between the Claims (% of GDP) of Azerbaijan in 2004 and the Claims (% of GDP) of Maldives in 2009?
Keep it short and to the point. -52.05. What is the difference between the Claims (% of GDP) in Least developed countries in 2005 and the Claims (% of GDP) in Sub-Saharan Africa (developing only) in 2006?
Make the answer very short. -60.02. What is the difference between the Claims (% of GDP) of Least developed countries in 2005 and the Claims (% of GDP) of Azerbaijan in 2006?
Ensure brevity in your answer.  3.29. What is the difference between the Claims (% of GDP) in Least developed countries in 2005 and the Claims (% of GDP) in Maldives in 2006?
Your answer should be compact. -32.36. What is the difference between the Claims (% of GDP) in Sub-Saharan Africa (developing only) in 2005 and the Claims (% of GDP) in Azerbaijan in 2006?
Offer a terse response. 62.05. What is the difference between the Claims (% of GDP) of Sub-Saharan Africa (developing only) in 2005 and the Claims (% of GDP) of Maldives in 2006?
Give a very brief answer. 26.4. What is the difference between the Claims (% of GDP) in Azerbaijan in 2005 and the Claims (% of GDP) in Maldives in 2006?
Provide a short and direct response. -36.85. What is the difference between the Claims (% of GDP) in Least developed countries in 2005 and the Claims (% of GDP) in Sub-Saharan Africa (developing only) in 2007?
Keep it short and to the point. -62.27. What is the difference between the Claims (% of GDP) in Least developed countries in 2005 and the Claims (% of GDP) in Azerbaijan in 2007?
Make the answer very short. -0.51. What is the difference between the Claims (% of GDP) in Least developed countries in 2005 and the Claims (% of GDP) in Maldives in 2007?
Provide a succinct answer. -46.74. What is the difference between the Claims (% of GDP) of Sub-Saharan Africa (developing only) in 2005 and the Claims (% of GDP) of Azerbaijan in 2007?
Your answer should be very brief. 58.25. What is the difference between the Claims (% of GDP) in Sub-Saharan Africa (developing only) in 2005 and the Claims (% of GDP) in Maldives in 2007?
Your answer should be very brief. 12.01. What is the difference between the Claims (% of GDP) of Azerbaijan in 2005 and the Claims (% of GDP) of Maldives in 2007?
Ensure brevity in your answer.  -51.23. What is the difference between the Claims (% of GDP) of Least developed countries in 2005 and the Claims (% of GDP) of Sub-Saharan Africa (developing only) in 2008?
Provide a short and direct response. -49.44. What is the difference between the Claims (% of GDP) in Least developed countries in 2005 and the Claims (% of GDP) in Azerbaijan in 2008?
Your answer should be compact. -1.9. What is the difference between the Claims (% of GDP) in Least developed countries in 2005 and the Claims (% of GDP) in Maldives in 2008?
Your answer should be very brief. -50.82. What is the difference between the Claims (% of GDP) in Sub-Saharan Africa (developing only) in 2005 and the Claims (% of GDP) in Azerbaijan in 2008?
Keep it short and to the point. 56.85. What is the difference between the Claims (% of GDP) in Sub-Saharan Africa (developing only) in 2005 and the Claims (% of GDP) in Maldives in 2008?
Provide a succinct answer. 7.94. What is the difference between the Claims (% of GDP) in Azerbaijan in 2005 and the Claims (% of GDP) in Maldives in 2008?
Make the answer very short. -55.31. What is the difference between the Claims (% of GDP) of Least developed countries in 2005 and the Claims (% of GDP) of Sub-Saharan Africa (developing only) in 2009?
Provide a short and direct response. -58.14. What is the difference between the Claims (% of GDP) in Least developed countries in 2005 and the Claims (% of GDP) in Azerbaijan in 2009?
Offer a very short reply. -7.36. What is the difference between the Claims (% of GDP) in Least developed countries in 2005 and the Claims (% of GDP) in Maldives in 2009?
Your answer should be very brief. -47.07. What is the difference between the Claims (% of GDP) of Sub-Saharan Africa (developing only) in 2005 and the Claims (% of GDP) of Azerbaijan in 2009?
Keep it short and to the point. 51.39. What is the difference between the Claims (% of GDP) in Sub-Saharan Africa (developing only) in 2005 and the Claims (% of GDP) in Maldives in 2009?
Your answer should be very brief. 11.68. What is the difference between the Claims (% of GDP) in Azerbaijan in 2005 and the Claims (% of GDP) in Maldives in 2009?
Ensure brevity in your answer.  -51.56. What is the difference between the Claims (% of GDP) in Least developed countries in 2006 and the Claims (% of GDP) in Sub-Saharan Africa (developing only) in 2007?
Keep it short and to the point. -61.75. What is the difference between the Claims (% of GDP) in Least developed countries in 2006 and the Claims (% of GDP) in Azerbaijan in 2007?
Offer a very short reply. 0.01. What is the difference between the Claims (% of GDP) of Least developed countries in 2006 and the Claims (% of GDP) of Maldives in 2007?
Keep it short and to the point. -46.22. What is the difference between the Claims (% of GDP) in Sub-Saharan Africa (developing only) in 2006 and the Claims (% of GDP) in Azerbaijan in 2007?
Provide a short and direct response. 59.51. What is the difference between the Claims (% of GDP) in Sub-Saharan Africa (developing only) in 2006 and the Claims (% of GDP) in Maldives in 2007?
Offer a very short reply. 13.27. What is the difference between the Claims (% of GDP) of Azerbaijan in 2006 and the Claims (% of GDP) of Maldives in 2007?
Provide a short and direct response. -50.03. What is the difference between the Claims (% of GDP) of Least developed countries in 2006 and the Claims (% of GDP) of Sub-Saharan Africa (developing only) in 2008?
Give a very brief answer. -48.92. What is the difference between the Claims (% of GDP) in Least developed countries in 2006 and the Claims (% of GDP) in Azerbaijan in 2008?
Provide a succinct answer. -1.38. What is the difference between the Claims (% of GDP) of Least developed countries in 2006 and the Claims (% of GDP) of Maldives in 2008?
Your answer should be very brief. -50.3. What is the difference between the Claims (% of GDP) in Sub-Saharan Africa (developing only) in 2006 and the Claims (% of GDP) in Azerbaijan in 2008?
Offer a terse response. 58.11. What is the difference between the Claims (% of GDP) in Sub-Saharan Africa (developing only) in 2006 and the Claims (% of GDP) in Maldives in 2008?
Offer a very short reply. 9.2. What is the difference between the Claims (% of GDP) in Azerbaijan in 2006 and the Claims (% of GDP) in Maldives in 2008?
Your answer should be compact. -54.11. What is the difference between the Claims (% of GDP) of Least developed countries in 2006 and the Claims (% of GDP) of Sub-Saharan Africa (developing only) in 2009?
Provide a succinct answer. -57.62. What is the difference between the Claims (% of GDP) in Least developed countries in 2006 and the Claims (% of GDP) in Azerbaijan in 2009?
Offer a very short reply. -6.84. What is the difference between the Claims (% of GDP) of Least developed countries in 2006 and the Claims (% of GDP) of Maldives in 2009?
Offer a terse response. -46.55. What is the difference between the Claims (% of GDP) in Sub-Saharan Africa (developing only) in 2006 and the Claims (% of GDP) in Azerbaijan in 2009?
Provide a succinct answer. 52.66. What is the difference between the Claims (% of GDP) of Sub-Saharan Africa (developing only) in 2006 and the Claims (% of GDP) of Maldives in 2009?
Provide a short and direct response. 12.94. What is the difference between the Claims (% of GDP) of Azerbaijan in 2006 and the Claims (% of GDP) of Maldives in 2009?
Your response must be concise. -50.36. What is the difference between the Claims (% of GDP) of Least developed countries in 2007 and the Claims (% of GDP) of Sub-Saharan Africa (developing only) in 2008?
Your answer should be compact. -48.25. What is the difference between the Claims (% of GDP) of Least developed countries in 2007 and the Claims (% of GDP) of Azerbaijan in 2008?
Offer a terse response. -0.71. What is the difference between the Claims (% of GDP) of Least developed countries in 2007 and the Claims (% of GDP) of Maldives in 2008?
Your answer should be very brief. -49.63. What is the difference between the Claims (% of GDP) in Sub-Saharan Africa (developing only) in 2007 and the Claims (% of GDP) in Azerbaijan in 2008?
Your answer should be very brief. 60.36. What is the difference between the Claims (% of GDP) in Sub-Saharan Africa (developing only) in 2007 and the Claims (% of GDP) in Maldives in 2008?
Give a very brief answer. 11.45. What is the difference between the Claims (% of GDP) in Azerbaijan in 2007 and the Claims (% of GDP) in Maldives in 2008?
Provide a short and direct response. -50.31. What is the difference between the Claims (% of GDP) of Least developed countries in 2007 and the Claims (% of GDP) of Sub-Saharan Africa (developing only) in 2009?
Keep it short and to the point. -56.95. What is the difference between the Claims (% of GDP) in Least developed countries in 2007 and the Claims (% of GDP) in Azerbaijan in 2009?
Your answer should be very brief. -6.17. What is the difference between the Claims (% of GDP) of Least developed countries in 2007 and the Claims (% of GDP) of Maldives in 2009?
Keep it short and to the point. -45.88. What is the difference between the Claims (% of GDP) of Sub-Saharan Africa (developing only) in 2007 and the Claims (% of GDP) of Azerbaijan in 2009?
Your response must be concise. 54.91. What is the difference between the Claims (% of GDP) of Sub-Saharan Africa (developing only) in 2007 and the Claims (% of GDP) of Maldives in 2009?
Offer a terse response. 15.19. What is the difference between the Claims (% of GDP) in Azerbaijan in 2007 and the Claims (% of GDP) in Maldives in 2009?
Ensure brevity in your answer.  -46.56. What is the difference between the Claims (% of GDP) of Least developed countries in 2008 and the Claims (% of GDP) of Sub-Saharan Africa (developing only) in 2009?
Provide a succinct answer. -55.07. What is the difference between the Claims (% of GDP) of Least developed countries in 2008 and the Claims (% of GDP) of Azerbaijan in 2009?
Keep it short and to the point. -4.29. What is the difference between the Claims (% of GDP) of Least developed countries in 2008 and the Claims (% of GDP) of Maldives in 2009?
Give a very brief answer. -44.01. What is the difference between the Claims (% of GDP) in Sub-Saharan Africa (developing only) in 2008 and the Claims (% of GDP) in Azerbaijan in 2009?
Your response must be concise. 42.08. What is the difference between the Claims (% of GDP) of Sub-Saharan Africa (developing only) in 2008 and the Claims (% of GDP) of Maldives in 2009?
Give a very brief answer. 2.36. What is the difference between the Claims (% of GDP) in Azerbaijan in 2008 and the Claims (% of GDP) in Maldives in 2009?
Provide a short and direct response. -45.17. What is the average Claims (% of GDP) in Least developed countries per year?
Offer a very short reply. 17.72. What is the average Claims (% of GDP) of Sub-Saharan Africa (developing only) per year?
Your response must be concise. 70.22. What is the average Claims (% of GDP) of Azerbaijan per year?
Offer a terse response. 13.73. What is the average Claims (% of GDP) in Maldives per year?
Ensure brevity in your answer.  43.5. In the year 2002, what is the difference between the Claims (% of GDP) in Least developed countries and Claims (% of GDP) in Sub-Saharan Africa (developing only)?
Offer a terse response. -38.64. In the year 2002, what is the difference between the Claims (% of GDP) of Least developed countries and Claims (% of GDP) of Azerbaijan?
Your answer should be compact. 8.98. In the year 2002, what is the difference between the Claims (% of GDP) in Least developed countries and Claims (% of GDP) in Maldives?
Provide a short and direct response. -3.66. In the year 2002, what is the difference between the Claims (% of GDP) of Sub-Saharan Africa (developing only) and Claims (% of GDP) of Azerbaijan?
Offer a very short reply. 47.62. In the year 2002, what is the difference between the Claims (% of GDP) of Sub-Saharan Africa (developing only) and Claims (% of GDP) of Maldives?
Provide a succinct answer. 34.98. In the year 2002, what is the difference between the Claims (% of GDP) in Azerbaijan and Claims (% of GDP) in Maldives?
Offer a very short reply. -12.64. In the year 2003, what is the difference between the Claims (% of GDP) in Least developed countries and Claims (% of GDP) in Sub-Saharan Africa (developing only)?
Your answer should be compact. -49.53. In the year 2003, what is the difference between the Claims (% of GDP) in Least developed countries and Claims (% of GDP) in Azerbaijan?
Your answer should be very brief. 7.82. In the year 2003, what is the difference between the Claims (% of GDP) in Least developed countries and Claims (% of GDP) in Maldives?
Your response must be concise. -1.22. In the year 2003, what is the difference between the Claims (% of GDP) of Sub-Saharan Africa (developing only) and Claims (% of GDP) of Azerbaijan?
Give a very brief answer. 57.35. In the year 2003, what is the difference between the Claims (% of GDP) in Sub-Saharan Africa (developing only) and Claims (% of GDP) in Maldives?
Offer a very short reply. 48.3. In the year 2003, what is the difference between the Claims (% of GDP) of Azerbaijan and Claims (% of GDP) of Maldives?
Ensure brevity in your answer.  -9.05. In the year 2004, what is the difference between the Claims (% of GDP) in Least developed countries and Claims (% of GDP) in Sub-Saharan Africa (developing only)?
Offer a very short reply. -55.13. In the year 2004, what is the difference between the Claims (% of GDP) of Least developed countries and Claims (% of GDP) of Azerbaijan?
Ensure brevity in your answer.  5.17. In the year 2004, what is the difference between the Claims (% of GDP) in Least developed countries and Claims (% of GDP) in Maldives?
Keep it short and to the point. -8.77. In the year 2004, what is the difference between the Claims (% of GDP) in Sub-Saharan Africa (developing only) and Claims (% of GDP) in Azerbaijan?
Provide a succinct answer. 60.3. In the year 2004, what is the difference between the Claims (% of GDP) in Sub-Saharan Africa (developing only) and Claims (% of GDP) in Maldives?
Your answer should be very brief. 46.36. In the year 2004, what is the difference between the Claims (% of GDP) of Azerbaijan and Claims (% of GDP) of Maldives?
Offer a terse response. -13.94. In the year 2005, what is the difference between the Claims (% of GDP) in Least developed countries and Claims (% of GDP) in Sub-Saharan Africa (developing only)?
Your answer should be very brief. -58.76. In the year 2005, what is the difference between the Claims (% of GDP) of Least developed countries and Claims (% of GDP) of Azerbaijan?
Make the answer very short. 4.49. In the year 2005, what is the difference between the Claims (% of GDP) in Least developed countries and Claims (% of GDP) in Maldives?
Provide a succinct answer. -27.54. In the year 2005, what is the difference between the Claims (% of GDP) in Sub-Saharan Africa (developing only) and Claims (% of GDP) in Azerbaijan?
Provide a succinct answer. 63.24. In the year 2005, what is the difference between the Claims (% of GDP) in Sub-Saharan Africa (developing only) and Claims (% of GDP) in Maldives?
Keep it short and to the point. 31.21. In the year 2005, what is the difference between the Claims (% of GDP) of Azerbaijan and Claims (% of GDP) of Maldives?
Offer a terse response. -32.03. In the year 2006, what is the difference between the Claims (% of GDP) of Least developed countries and Claims (% of GDP) of Sub-Saharan Africa (developing only)?
Make the answer very short. -59.5. In the year 2006, what is the difference between the Claims (% of GDP) of Least developed countries and Claims (% of GDP) of Azerbaijan?
Ensure brevity in your answer.  3.81. In the year 2006, what is the difference between the Claims (% of GDP) in Least developed countries and Claims (% of GDP) in Maldives?
Your answer should be very brief. -31.84. In the year 2006, what is the difference between the Claims (% of GDP) of Sub-Saharan Africa (developing only) and Claims (% of GDP) of Azerbaijan?
Your answer should be very brief. 63.31. In the year 2006, what is the difference between the Claims (% of GDP) in Sub-Saharan Africa (developing only) and Claims (% of GDP) in Maldives?
Make the answer very short. 27.66. In the year 2006, what is the difference between the Claims (% of GDP) in Azerbaijan and Claims (% of GDP) in Maldives?
Offer a terse response. -35.65. In the year 2007, what is the difference between the Claims (% of GDP) of Least developed countries and Claims (% of GDP) of Sub-Saharan Africa (developing only)?
Provide a succinct answer. -61.07. In the year 2007, what is the difference between the Claims (% of GDP) in Least developed countries and Claims (% of GDP) in Azerbaijan?
Your response must be concise. 0.68. In the year 2007, what is the difference between the Claims (% of GDP) of Least developed countries and Claims (% of GDP) of Maldives?
Your response must be concise. -45.55. In the year 2007, what is the difference between the Claims (% of GDP) of Sub-Saharan Africa (developing only) and Claims (% of GDP) of Azerbaijan?
Your answer should be compact. 61.76. In the year 2007, what is the difference between the Claims (% of GDP) of Sub-Saharan Africa (developing only) and Claims (% of GDP) of Maldives?
Offer a terse response. 15.52. In the year 2007, what is the difference between the Claims (% of GDP) of Azerbaijan and Claims (% of GDP) of Maldives?
Keep it short and to the point. -46.23. In the year 2008, what is the difference between the Claims (% of GDP) in Least developed countries and Claims (% of GDP) in Sub-Saharan Africa (developing only)?
Offer a terse response. -46.37. In the year 2008, what is the difference between the Claims (% of GDP) in Least developed countries and Claims (% of GDP) in Azerbaijan?
Provide a short and direct response. 1.16. In the year 2008, what is the difference between the Claims (% of GDP) in Least developed countries and Claims (% of GDP) in Maldives?
Your response must be concise. -47.75. In the year 2008, what is the difference between the Claims (% of GDP) of Sub-Saharan Africa (developing only) and Claims (% of GDP) of Azerbaijan?
Give a very brief answer. 47.53. In the year 2008, what is the difference between the Claims (% of GDP) of Sub-Saharan Africa (developing only) and Claims (% of GDP) of Maldives?
Make the answer very short. -1.38. In the year 2008, what is the difference between the Claims (% of GDP) in Azerbaijan and Claims (% of GDP) in Maldives?
Your answer should be compact. -48.91. In the year 2009, what is the difference between the Claims (% of GDP) in Least developed countries and Claims (% of GDP) in Sub-Saharan Africa (developing only)?
Offer a very short reply. -50.99. In the year 2009, what is the difference between the Claims (% of GDP) in Least developed countries and Claims (% of GDP) in Azerbaijan?
Offer a very short reply. -0.21. In the year 2009, what is the difference between the Claims (% of GDP) in Least developed countries and Claims (% of GDP) in Maldives?
Provide a short and direct response. -39.92. In the year 2009, what is the difference between the Claims (% of GDP) of Sub-Saharan Africa (developing only) and Claims (% of GDP) of Azerbaijan?
Ensure brevity in your answer.  50.78. In the year 2009, what is the difference between the Claims (% of GDP) in Sub-Saharan Africa (developing only) and Claims (% of GDP) in Maldives?
Your answer should be very brief. 11.07. In the year 2009, what is the difference between the Claims (% of GDP) of Azerbaijan and Claims (% of GDP) of Maldives?
Give a very brief answer. -39.71. What is the ratio of the Claims (% of GDP) of Least developed countries in 2002 to that in 2003?
Keep it short and to the point. 0.99. What is the ratio of the Claims (% of GDP) in Sub-Saharan Africa (developing only) in 2002 to that in 2003?
Ensure brevity in your answer.  0.83. What is the ratio of the Claims (% of GDP) in Azerbaijan in 2002 to that in 2003?
Ensure brevity in your answer.  0.85. What is the ratio of the Claims (% of GDP) of Maldives in 2002 to that in 2003?
Ensure brevity in your answer.  1.13. What is the ratio of the Claims (% of GDP) of Least developed countries in 2002 to that in 2004?
Make the answer very short. 0.98. What is the ratio of the Claims (% of GDP) of Sub-Saharan Africa (developing only) in 2002 to that in 2004?
Your answer should be very brief. 0.77. What is the ratio of the Claims (% of GDP) in Azerbaijan in 2002 to that in 2004?
Give a very brief answer. 0.64. What is the ratio of the Claims (% of GDP) of Maldives in 2002 to that in 2004?
Your answer should be compact. 0.79. What is the ratio of the Claims (% of GDP) of Least developed countries in 2002 to that in 2005?
Your answer should be very brief. 0.99. What is the ratio of the Claims (% of GDP) in Sub-Saharan Africa (developing only) in 2002 to that in 2005?
Make the answer very short. 0.73. What is the ratio of the Claims (% of GDP) of Azerbaijan in 2002 to that in 2005?
Offer a terse response. 0.61. What is the ratio of the Claims (% of GDP) of Maldives in 2002 to that in 2005?
Offer a very short reply. 0.45. What is the ratio of the Claims (% of GDP) of Least developed countries in 2002 to that in 2006?
Make the answer very short. 0.96. What is the ratio of the Claims (% of GDP) of Sub-Saharan Africa (developing only) in 2002 to that in 2006?
Make the answer very short. 0.72. What is the ratio of the Claims (% of GDP) of Azerbaijan in 2002 to that in 2006?
Offer a terse response. 0.55. What is the ratio of the Claims (% of GDP) in Maldives in 2002 to that in 2006?
Provide a short and direct response. 0.41. What is the ratio of the Claims (% of GDP) in Least developed countries in 2002 to that in 2007?
Provide a succinct answer. 0.93. What is the ratio of the Claims (% of GDP) in Sub-Saharan Africa (developing only) in 2002 to that in 2007?
Keep it short and to the point. 0.7. What is the ratio of the Claims (% of GDP) of Azerbaijan in 2002 to that in 2007?
Offer a very short reply. 0.43. What is the ratio of the Claims (% of GDP) in Maldives in 2002 to that in 2007?
Offer a terse response. 0.31. What is the ratio of the Claims (% of GDP) of Least developed countries in 2002 to that in 2008?
Provide a short and direct response. 0.84. What is the ratio of the Claims (% of GDP) of Sub-Saharan Africa (developing only) in 2002 to that in 2008?
Offer a terse response. 0.83. What is the ratio of the Claims (% of GDP) in Azerbaijan in 2002 to that in 2008?
Give a very brief answer. 0.39. What is the ratio of the Claims (% of GDP) of Maldives in 2002 to that in 2008?
Make the answer very short. 0.3. What is the ratio of the Claims (% of GDP) in Least developed countries in 2002 to that in 2009?
Provide a succinct answer. 0.69. What is the ratio of the Claims (% of GDP) of Sub-Saharan Africa (developing only) in 2002 to that in 2009?
Make the answer very short. 0.74. What is the ratio of the Claims (% of GDP) of Azerbaijan in 2002 to that in 2009?
Offer a terse response. 0.3. What is the ratio of the Claims (% of GDP) of Maldives in 2002 to that in 2009?
Provide a succinct answer. 0.31. What is the ratio of the Claims (% of GDP) of Least developed countries in 2003 to that in 2004?
Keep it short and to the point. 0.99. What is the ratio of the Claims (% of GDP) in Sub-Saharan Africa (developing only) in 2003 to that in 2004?
Provide a succinct answer. 0.92. What is the ratio of the Claims (% of GDP) of Azerbaijan in 2003 to that in 2004?
Give a very brief answer. 0.75. What is the ratio of the Claims (% of GDP) in Maldives in 2003 to that in 2004?
Make the answer very short. 0.69. What is the ratio of the Claims (% of GDP) of Least developed countries in 2003 to that in 2005?
Provide a succinct answer. 1. What is the ratio of the Claims (% of GDP) in Sub-Saharan Africa (developing only) in 2003 to that in 2005?
Your response must be concise. 0.88. What is the ratio of the Claims (% of GDP) in Azerbaijan in 2003 to that in 2005?
Keep it short and to the point. 0.72. What is the ratio of the Claims (% of GDP) of Maldives in 2003 to that in 2005?
Your response must be concise. 0.4. What is the ratio of the Claims (% of GDP) in Sub-Saharan Africa (developing only) in 2003 to that in 2006?
Make the answer very short. 0.86. What is the ratio of the Claims (% of GDP) in Azerbaijan in 2003 to that in 2006?
Offer a very short reply. 0.65. What is the ratio of the Claims (% of GDP) of Maldives in 2003 to that in 2006?
Make the answer very short. 0.36. What is the ratio of the Claims (% of GDP) in Least developed countries in 2003 to that in 2007?
Your answer should be very brief. 0.93. What is the ratio of the Claims (% of GDP) of Sub-Saharan Africa (developing only) in 2003 to that in 2007?
Offer a terse response. 0.84. What is the ratio of the Claims (% of GDP) of Azerbaijan in 2003 to that in 2007?
Provide a succinct answer. 0.5. What is the ratio of the Claims (% of GDP) of Maldives in 2003 to that in 2007?
Your answer should be compact. 0.28. What is the ratio of the Claims (% of GDP) in Least developed countries in 2003 to that in 2008?
Your response must be concise. 0.84. What is the ratio of the Claims (% of GDP) of Sub-Saharan Africa (developing only) in 2003 to that in 2008?
Make the answer very short. 1. What is the ratio of the Claims (% of GDP) of Azerbaijan in 2003 to that in 2008?
Give a very brief answer. 0.46. What is the ratio of the Claims (% of GDP) in Maldives in 2003 to that in 2008?
Provide a succinct answer. 0.26. What is the ratio of the Claims (% of GDP) of Least developed countries in 2003 to that in 2009?
Your answer should be compact. 0.69. What is the ratio of the Claims (% of GDP) of Sub-Saharan Africa (developing only) in 2003 to that in 2009?
Provide a short and direct response. 0.88. What is the ratio of the Claims (% of GDP) in Azerbaijan in 2003 to that in 2009?
Offer a very short reply. 0.36. What is the ratio of the Claims (% of GDP) of Maldives in 2003 to that in 2009?
Your response must be concise. 0.28. What is the ratio of the Claims (% of GDP) in Least developed countries in 2004 to that in 2005?
Provide a short and direct response. 1.01. What is the ratio of the Claims (% of GDP) of Sub-Saharan Africa (developing only) in 2004 to that in 2005?
Your answer should be very brief. 0.95. What is the ratio of the Claims (% of GDP) of Azerbaijan in 2004 to that in 2005?
Your answer should be compact. 0.96. What is the ratio of the Claims (% of GDP) of Maldives in 2004 to that in 2005?
Ensure brevity in your answer.  0.58. What is the ratio of the Claims (% of GDP) in Least developed countries in 2004 to that in 2006?
Provide a succinct answer. 0.98. What is the ratio of the Claims (% of GDP) of Sub-Saharan Africa (developing only) in 2004 to that in 2006?
Your response must be concise. 0.94. What is the ratio of the Claims (% of GDP) in Azerbaijan in 2004 to that in 2006?
Provide a short and direct response. 0.87. What is the ratio of the Claims (% of GDP) in Maldives in 2004 to that in 2006?
Your answer should be very brief. 0.52. What is the ratio of the Claims (% of GDP) in Least developed countries in 2004 to that in 2007?
Offer a terse response. 0.94. What is the ratio of the Claims (% of GDP) of Sub-Saharan Africa (developing only) in 2004 to that in 2007?
Provide a succinct answer. 0.91. What is the ratio of the Claims (% of GDP) of Azerbaijan in 2004 to that in 2007?
Provide a short and direct response. 0.67. What is the ratio of the Claims (% of GDP) of Maldives in 2004 to that in 2007?
Offer a terse response. 0.4. What is the ratio of the Claims (% of GDP) of Least developed countries in 2004 to that in 2008?
Your answer should be very brief. 0.85. What is the ratio of the Claims (% of GDP) in Sub-Saharan Africa (developing only) in 2004 to that in 2008?
Ensure brevity in your answer.  1.09. What is the ratio of the Claims (% of GDP) in Azerbaijan in 2004 to that in 2008?
Provide a succinct answer. 0.62. What is the ratio of the Claims (% of GDP) of Maldives in 2004 to that in 2008?
Make the answer very short. 0.38. What is the ratio of the Claims (% of GDP) of Least developed countries in 2004 to that in 2009?
Provide a short and direct response. 0.7. What is the ratio of the Claims (% of GDP) of Sub-Saharan Africa (developing only) in 2004 to that in 2009?
Keep it short and to the point. 0.96. What is the ratio of the Claims (% of GDP) of Azerbaijan in 2004 to that in 2009?
Your answer should be very brief. 0.48. What is the ratio of the Claims (% of GDP) in Maldives in 2004 to that in 2009?
Your response must be concise. 0.4. What is the ratio of the Claims (% of GDP) of Least developed countries in 2005 to that in 2006?
Make the answer very short. 0.97. What is the ratio of the Claims (% of GDP) in Sub-Saharan Africa (developing only) in 2005 to that in 2006?
Offer a terse response. 0.98. What is the ratio of the Claims (% of GDP) in Azerbaijan in 2005 to that in 2006?
Provide a short and direct response. 0.91. What is the ratio of the Claims (% of GDP) in Maldives in 2005 to that in 2006?
Your answer should be very brief. 0.9. What is the ratio of the Claims (% of GDP) in Least developed countries in 2005 to that in 2007?
Your response must be concise. 0.93. What is the ratio of the Claims (% of GDP) in Sub-Saharan Africa (developing only) in 2005 to that in 2007?
Make the answer very short. 0.96. What is the ratio of the Claims (% of GDP) in Azerbaijan in 2005 to that in 2007?
Provide a succinct answer. 0.7. What is the ratio of the Claims (% of GDP) of Maldives in 2005 to that in 2007?
Your response must be concise. 0.69. What is the ratio of the Claims (% of GDP) of Least developed countries in 2005 to that in 2008?
Your answer should be compact. 0.84. What is the ratio of the Claims (% of GDP) in Sub-Saharan Africa (developing only) in 2005 to that in 2008?
Offer a terse response. 1.14. What is the ratio of the Claims (% of GDP) in Azerbaijan in 2005 to that in 2008?
Your response must be concise. 0.65. What is the ratio of the Claims (% of GDP) in Maldives in 2005 to that in 2008?
Offer a very short reply. 0.65. What is the ratio of the Claims (% of GDP) of Least developed countries in 2005 to that in 2009?
Make the answer very short. 0.69. What is the ratio of the Claims (% of GDP) of Sub-Saharan Africa (developing only) in 2005 to that in 2009?
Ensure brevity in your answer.  1.01. What is the ratio of the Claims (% of GDP) in Azerbaijan in 2005 to that in 2009?
Make the answer very short. 0.5. What is the ratio of the Claims (% of GDP) in Maldives in 2005 to that in 2009?
Ensure brevity in your answer.  0.69. What is the ratio of the Claims (% of GDP) of Least developed countries in 2006 to that in 2007?
Offer a terse response. 0.96. What is the ratio of the Claims (% of GDP) of Sub-Saharan Africa (developing only) in 2006 to that in 2007?
Give a very brief answer. 0.97. What is the ratio of the Claims (% of GDP) of Azerbaijan in 2006 to that in 2007?
Keep it short and to the point. 0.77. What is the ratio of the Claims (% of GDP) of Maldives in 2006 to that in 2007?
Provide a succinct answer. 0.77. What is the ratio of the Claims (% of GDP) of Least developed countries in 2006 to that in 2008?
Your answer should be very brief. 0.87. What is the ratio of the Claims (% of GDP) in Sub-Saharan Africa (developing only) in 2006 to that in 2008?
Ensure brevity in your answer.  1.16. What is the ratio of the Claims (% of GDP) of Azerbaijan in 2006 to that in 2008?
Your answer should be compact. 0.71. What is the ratio of the Claims (% of GDP) of Maldives in 2006 to that in 2008?
Make the answer very short. 0.72. What is the ratio of the Claims (% of GDP) in Least developed countries in 2006 to that in 2009?
Provide a short and direct response. 0.72. What is the ratio of the Claims (% of GDP) in Sub-Saharan Africa (developing only) in 2006 to that in 2009?
Give a very brief answer. 1.03. What is the ratio of the Claims (% of GDP) of Azerbaijan in 2006 to that in 2009?
Your answer should be very brief. 0.55. What is the ratio of the Claims (% of GDP) of Maldives in 2006 to that in 2009?
Your answer should be very brief. 0.77. What is the ratio of the Claims (% of GDP) of Least developed countries in 2007 to that in 2008?
Give a very brief answer. 0.9. What is the ratio of the Claims (% of GDP) of Sub-Saharan Africa (developing only) in 2007 to that in 2008?
Give a very brief answer. 1.2. What is the ratio of the Claims (% of GDP) of Azerbaijan in 2007 to that in 2008?
Offer a terse response. 0.92. What is the ratio of the Claims (% of GDP) of Maldives in 2007 to that in 2008?
Provide a short and direct response. 0.94. What is the ratio of the Claims (% of GDP) of Least developed countries in 2007 to that in 2009?
Provide a succinct answer. 0.74. What is the ratio of the Claims (% of GDP) in Sub-Saharan Africa (developing only) in 2007 to that in 2009?
Provide a succinct answer. 1.06. What is the ratio of the Claims (% of GDP) of Azerbaijan in 2007 to that in 2009?
Ensure brevity in your answer.  0.71. What is the ratio of the Claims (% of GDP) in Least developed countries in 2008 to that in 2009?
Provide a succinct answer. 0.83. What is the ratio of the Claims (% of GDP) of Sub-Saharan Africa (developing only) in 2008 to that in 2009?
Keep it short and to the point. 0.88. What is the ratio of the Claims (% of GDP) of Azerbaijan in 2008 to that in 2009?
Your answer should be very brief. 0.77. What is the ratio of the Claims (% of GDP) of Maldives in 2008 to that in 2009?
Offer a terse response. 1.06. What is the difference between the highest and the second highest Claims (% of GDP) of Least developed countries?
Give a very brief answer. 4.08. What is the difference between the highest and the second highest Claims (% of GDP) in Sub-Saharan Africa (developing only)?
Keep it short and to the point. 2.25. What is the difference between the highest and the second highest Claims (% of GDP) of Azerbaijan?
Your response must be concise. 5.46. What is the difference between the highest and the second highest Claims (% of GDP) in Maldives?
Keep it short and to the point. 3.74. What is the difference between the highest and the lowest Claims (% of GDP) in Least developed countries?
Offer a very short reply. 7.24. What is the difference between the highest and the lowest Claims (% of GDP) in Sub-Saharan Africa (developing only)?
Your answer should be compact. 23.72. What is the difference between the highest and the lowest Claims (% of GDP) of Azerbaijan?
Offer a very short reply. 16.43. What is the difference between the highest and the lowest Claims (% of GDP) of Maldives?
Make the answer very short. 49.59. 